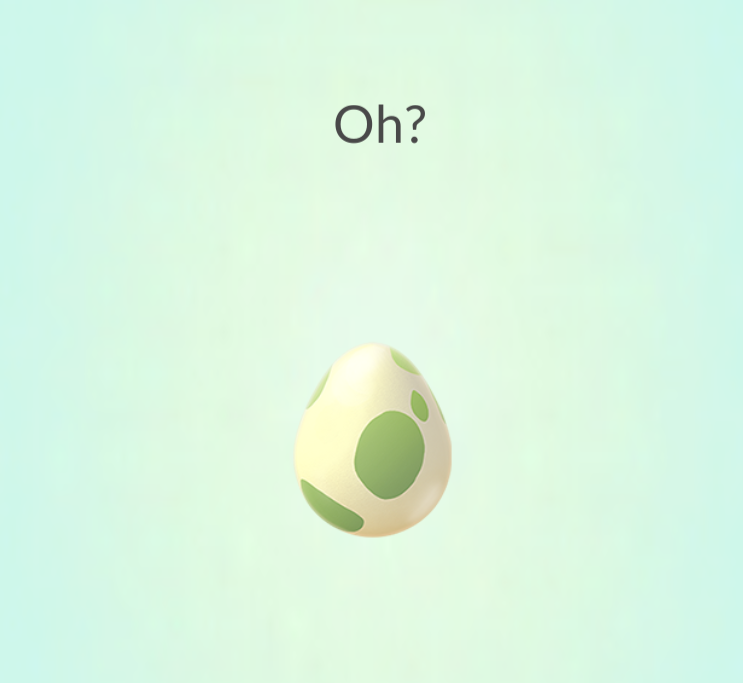How might the hatching of this egg be integrated into gameplay mechanics? In the context of an AR game, the hatching of this egg could be a central gameplay element. Players might need to complete tasks or challenges to gather the necessary items to encourage the egg to hatch. Once it does, the creature that emerges could provide new abilities or unlock further areas of the game, adding layers of strategy and interaction. 